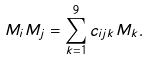Convert formula to latex. <formula><loc_0><loc_0><loc_500><loc_500>M _ { i } M _ { j } = \sum _ { k = 1 } ^ { 9 } c _ { i j k } M _ { k } .</formula> 